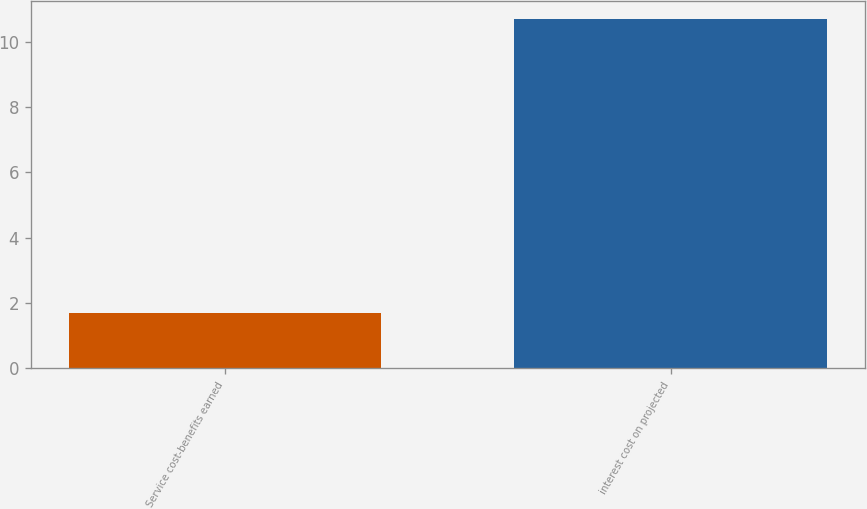Convert chart to OTSL. <chart><loc_0><loc_0><loc_500><loc_500><bar_chart><fcel>Service cost-benefits earned<fcel>interest cost on projected<nl><fcel>1.7<fcel>10.7<nl></chart> 